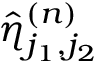<formula> <loc_0><loc_0><loc_500><loc_500>\hat { \eta } _ { j _ { 1 } , j _ { 2 } } ^ { ( n ) }</formula> 